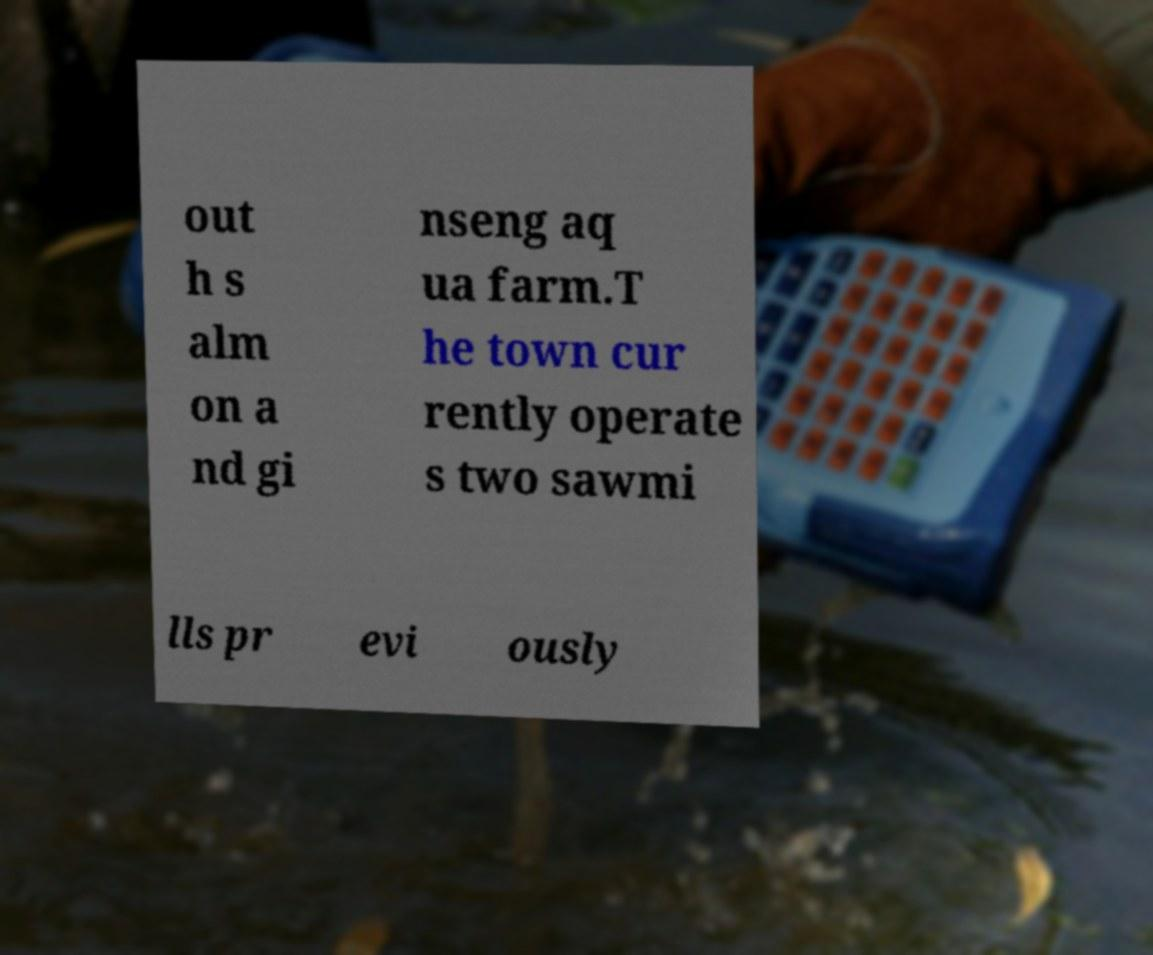Could you extract and type out the text from this image? out h s alm on a nd gi nseng aq ua farm.T he town cur rently operate s two sawmi lls pr evi ously 